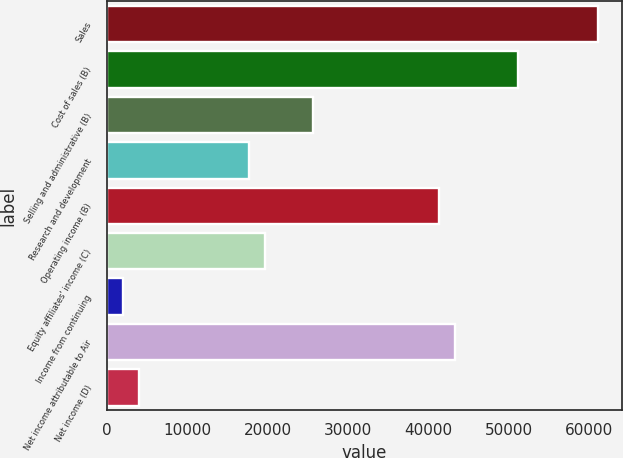<chart> <loc_0><loc_0><loc_500><loc_500><bar_chart><fcel>Sales<fcel>Cost of sales (B)<fcel>Selling and administrative (B)<fcel>Research and development<fcel>Operating income (B)<fcel>Equity affiliates' income (C)<fcel>Income from continuing<fcel>Net income attributable to Air<fcel>Net income (D)<nl><fcel>61063.3<fcel>51214.9<fcel>25609<fcel>17730.3<fcel>41366.5<fcel>19700<fcel>1972.88<fcel>43336.2<fcel>3942.56<nl></chart> 